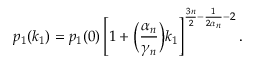<formula> <loc_0><loc_0><loc_500><loc_500>p _ { 1 } ( k _ { 1 } ) = p _ { 1 } ( 0 ) \left [ 1 + \left ( \frac { \alpha _ { n } } { \gamma _ { n } } \right ) k _ { 1 } \right ] ^ { \frac { 3 n } { 2 } - \frac { 1 } { 2 \alpha _ { n } } - 2 } .</formula> 